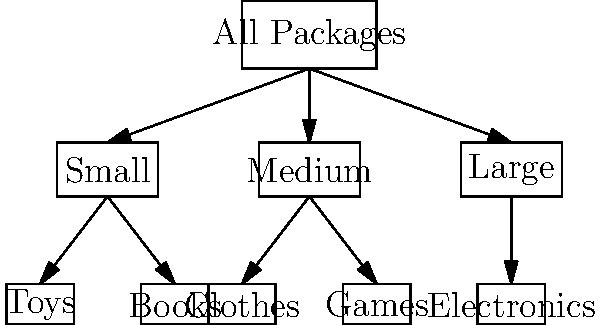As a working mom organizing Christmas packages for your children, you decide to create a tree diagram to sort the gifts by size and type. Given the diagram above, what is the total number of leaf nodes (categories at the bottom level) in this tree structure? To determine the number of leaf nodes in this tree diagram, we need to follow these steps:

1. Identify the levels of the tree:
   - Level 1 (Root): All Packages
   - Level 2: Small, Medium, Large
   - Level 3 (Leaves): Toys, Books, Clothes, Games, Electronics

2. Count the leaf nodes:
   - Under "Small": Toys, Books
   - Under "Medium": Clothes, Games
   - Under "Large": Electronics

3. Sum up the leaf nodes:
   2 (Small) + 2 (Medium) + 1 (Large) = 5 leaf nodes

The leaf nodes represent the most specific categories in our sorting system, which are the individual types of gifts (Toys, Books, Clothes, Games, and Electronics) at the bottom level of the tree.
Answer: 5 leaf nodes 